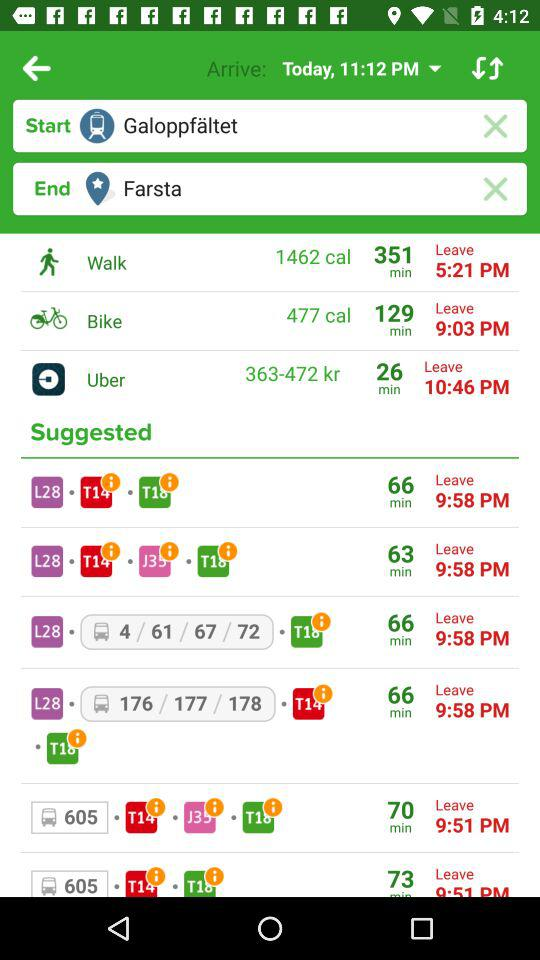At what time does Uber leave? An Uber leaves at 10:46 PM. 